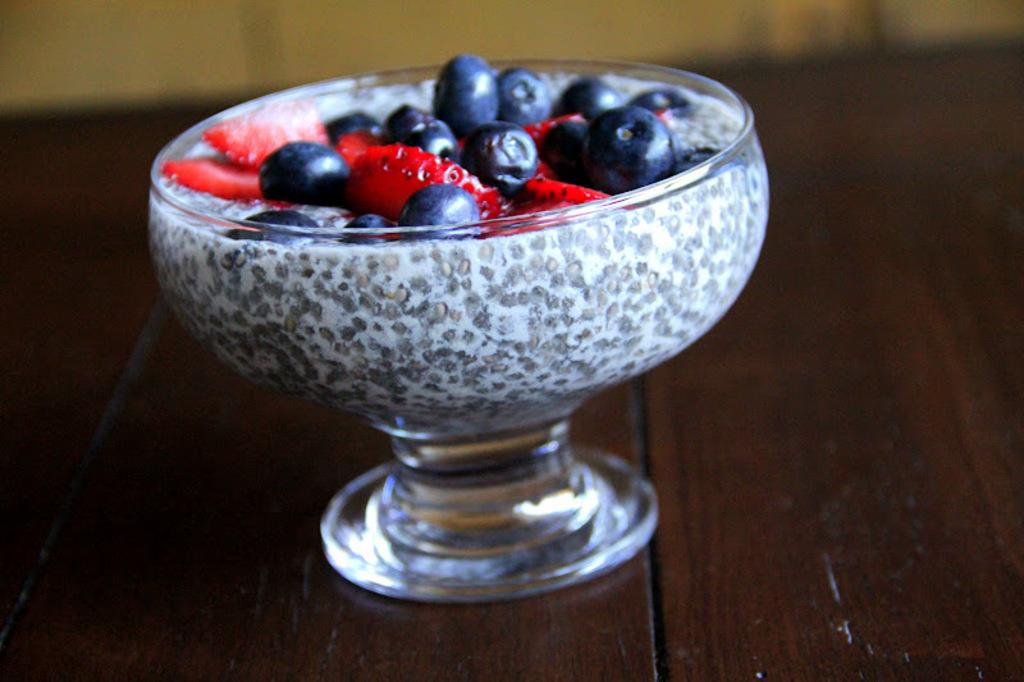What type of food can be seen in the image? There are fruits in the image. How are the fruits arranged or stored in the image? The fruits are kept in a bowl. Where is the bowl located in the image? The bowl is in the middle of the image. What is the bowl placed on in the image? The bowl is placed on a wooden object. What type of wrist accessory is visible in the image? There is no wrist accessory present in the image. What message of hope can be seen in the image? There is no message of hope depicted in the image; it features fruits in a bowl. 